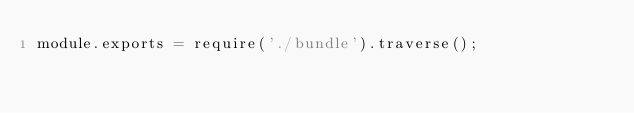<code> <loc_0><loc_0><loc_500><loc_500><_JavaScript_>module.exports = require('./bundle').traverse();
</code> 